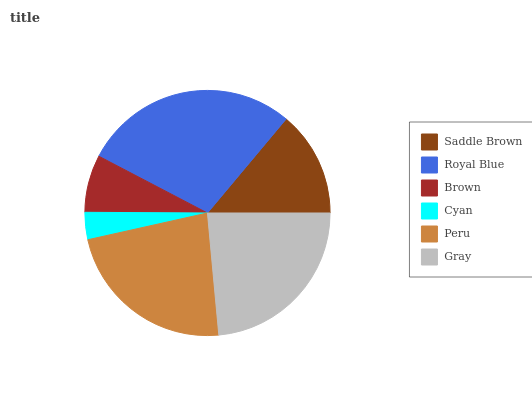Is Cyan the minimum?
Answer yes or no. Yes. Is Royal Blue the maximum?
Answer yes or no. Yes. Is Brown the minimum?
Answer yes or no. No. Is Brown the maximum?
Answer yes or no. No. Is Royal Blue greater than Brown?
Answer yes or no. Yes. Is Brown less than Royal Blue?
Answer yes or no. Yes. Is Brown greater than Royal Blue?
Answer yes or no. No. Is Royal Blue less than Brown?
Answer yes or no. No. Is Peru the high median?
Answer yes or no. Yes. Is Saddle Brown the low median?
Answer yes or no. Yes. Is Royal Blue the high median?
Answer yes or no. No. Is Cyan the low median?
Answer yes or no. No. 